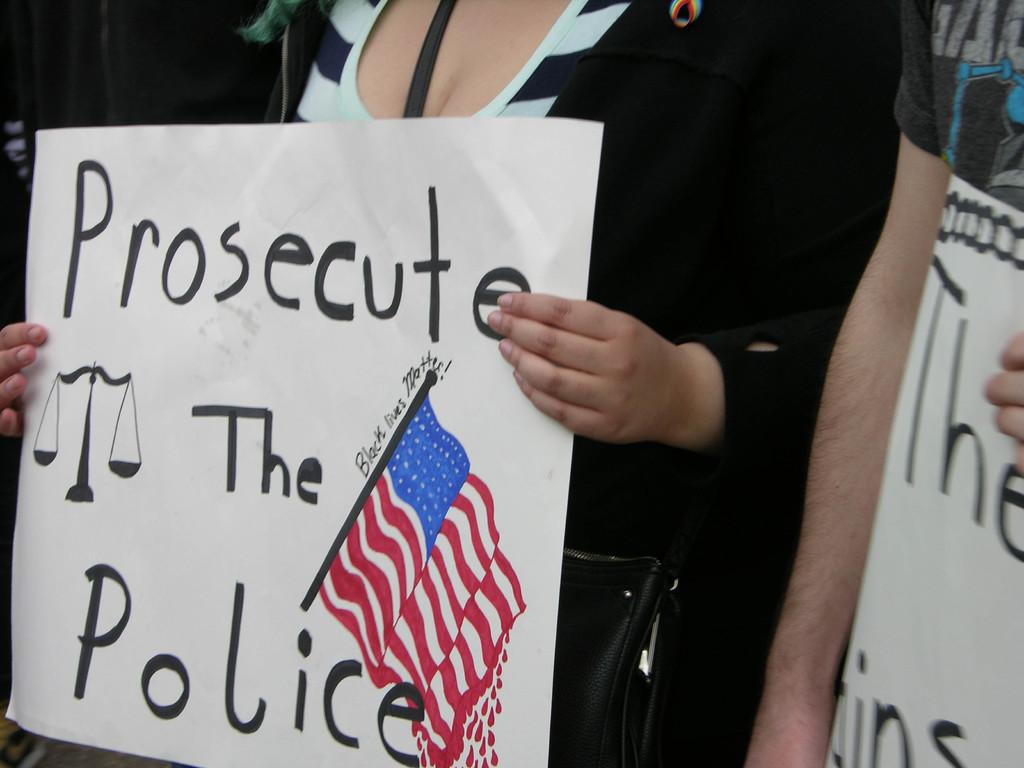<image>
Give a short and clear explanation of the subsequent image. woman holding poster stating prosecute the police and it has flag on it 